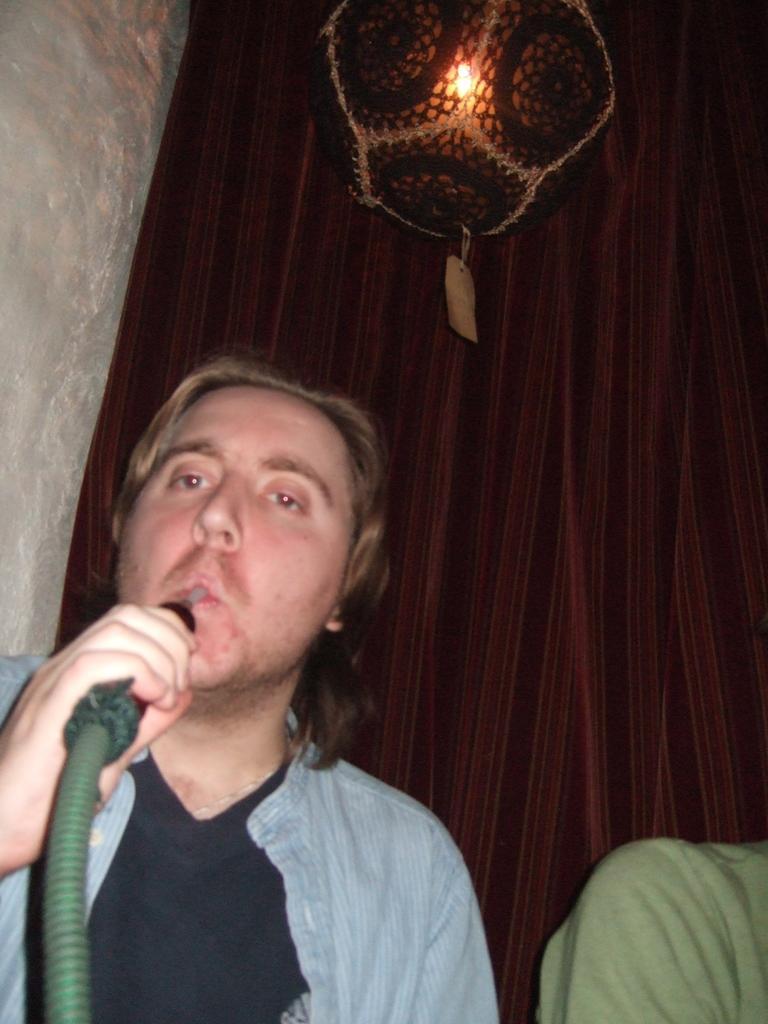Can you describe this image briefly? Here we can see a person holding a pipe with his hand and there is a person. In the background we can see a curtain, wall, and a light. 